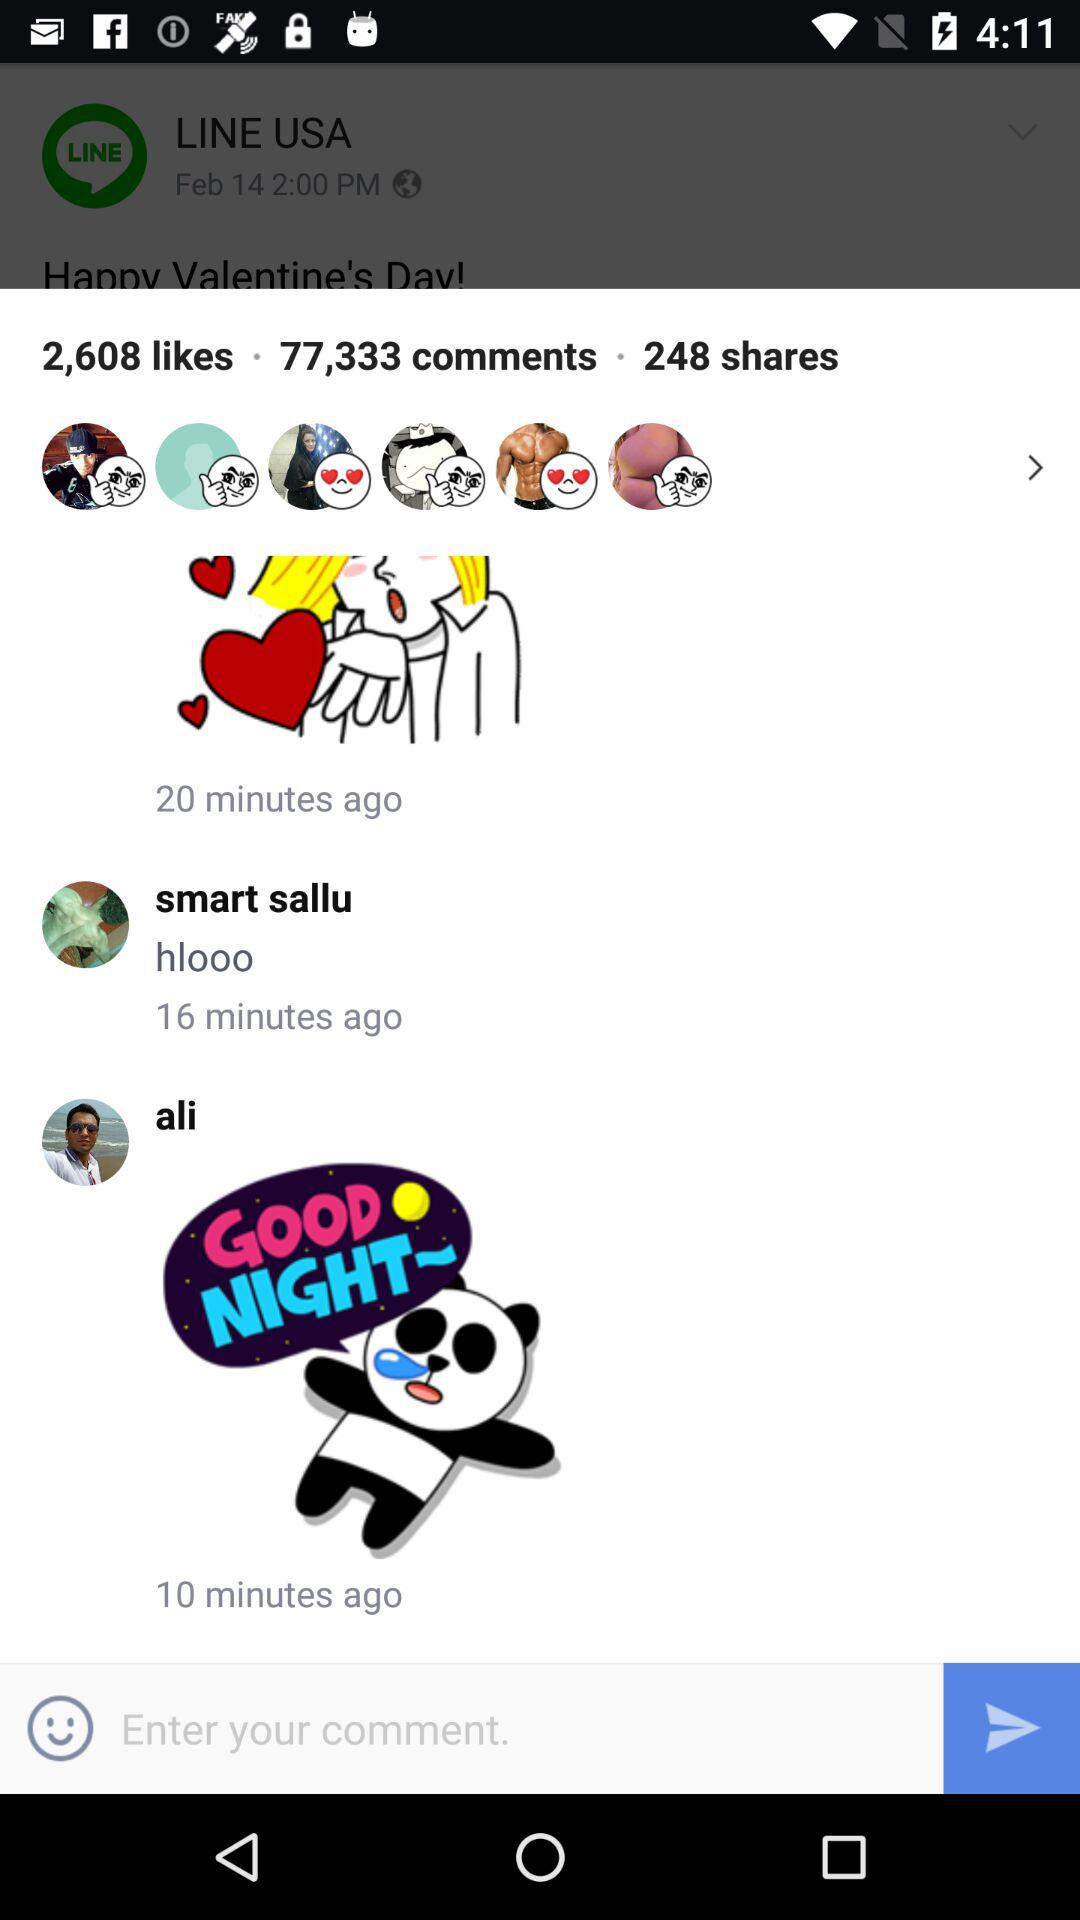How many comments are there on the post?
Answer the question using a single word or phrase. 77,333 